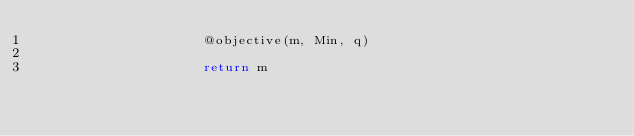Convert code to text. <code><loc_0><loc_0><loc_500><loc_500><_Julia_>                     @objective(m, Min, q)

                     return m

                    </code> 